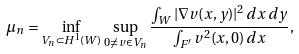Convert formula to latex. <formula><loc_0><loc_0><loc_500><loc_500>\mu _ { n } = \inf _ { V _ { n } \subset H ^ { 1 } ( W ) } \, \sup _ { 0 \neq v \in V _ { n } } \frac { \int _ { W } | \nabla v ( x , y ) | ^ { 2 } \, d x \, d y } { \int _ { F ^ { \prime } } v ^ { 2 } ( x , 0 ) \, d x } ,</formula> 